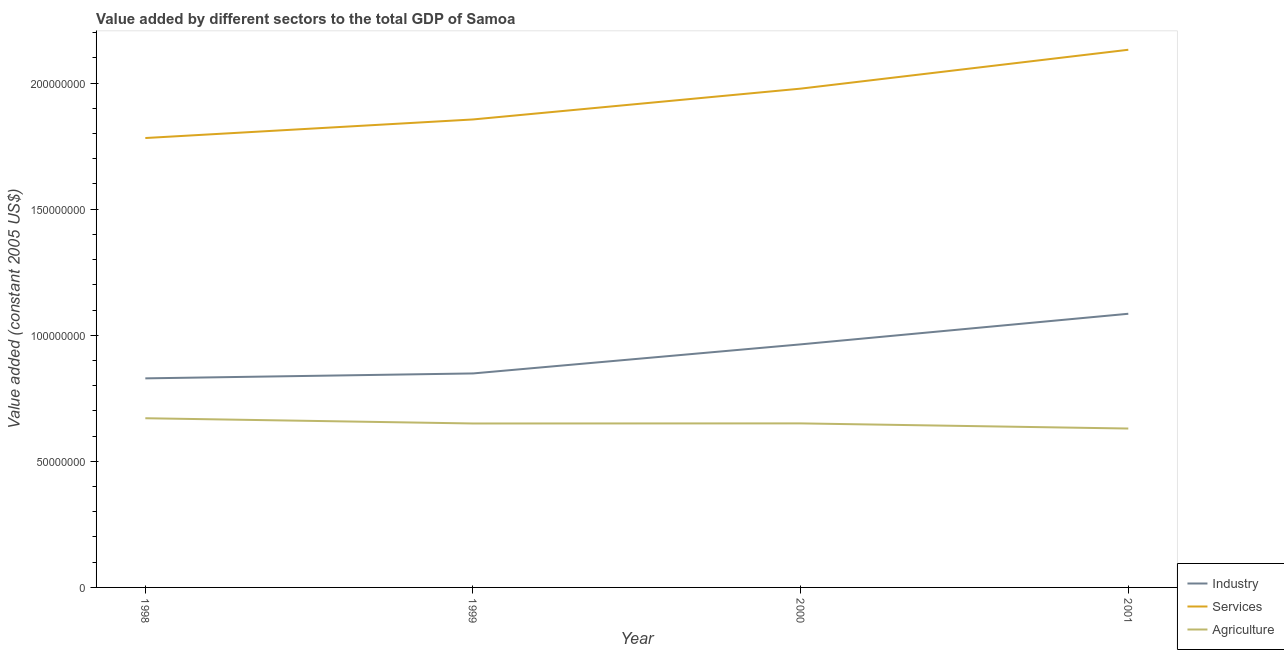Does the line corresponding to value added by services intersect with the line corresponding to value added by industrial sector?
Offer a very short reply. No. What is the value added by agricultural sector in 1999?
Provide a succinct answer. 6.50e+07. Across all years, what is the maximum value added by services?
Provide a short and direct response. 2.13e+08. Across all years, what is the minimum value added by services?
Ensure brevity in your answer.  1.78e+08. In which year was the value added by services minimum?
Offer a very short reply. 1998. What is the total value added by industrial sector in the graph?
Give a very brief answer. 3.73e+08. What is the difference between the value added by agricultural sector in 2000 and that in 2001?
Keep it short and to the point. 2.03e+06. What is the difference between the value added by services in 1999 and the value added by industrial sector in 2000?
Your answer should be very brief. 8.92e+07. What is the average value added by agricultural sector per year?
Make the answer very short. 6.50e+07. In the year 1999, what is the difference between the value added by agricultural sector and value added by services?
Provide a short and direct response. -1.21e+08. In how many years, is the value added by industrial sector greater than 80000000 US$?
Keep it short and to the point. 4. What is the ratio of the value added by services in 2000 to that in 2001?
Your response must be concise. 0.93. What is the difference between the highest and the second highest value added by agricultural sector?
Keep it short and to the point. 2.05e+06. What is the difference between the highest and the lowest value added by industrial sector?
Give a very brief answer. 2.56e+07. In how many years, is the value added by agricultural sector greater than the average value added by agricultural sector taken over all years?
Offer a terse response. 2. Is the sum of the value added by industrial sector in 1998 and 1999 greater than the maximum value added by services across all years?
Keep it short and to the point. No. Does the value added by industrial sector monotonically increase over the years?
Offer a terse response. Yes. How many lines are there?
Your response must be concise. 3. How many years are there in the graph?
Offer a very short reply. 4. How many legend labels are there?
Provide a succinct answer. 3. How are the legend labels stacked?
Offer a very short reply. Vertical. What is the title of the graph?
Provide a short and direct response. Value added by different sectors to the total GDP of Samoa. What is the label or title of the Y-axis?
Your answer should be very brief. Value added (constant 2005 US$). What is the Value added (constant 2005 US$) in Industry in 1998?
Provide a succinct answer. 8.29e+07. What is the Value added (constant 2005 US$) of Services in 1998?
Your answer should be compact. 1.78e+08. What is the Value added (constant 2005 US$) of Agriculture in 1998?
Provide a succinct answer. 6.71e+07. What is the Value added (constant 2005 US$) in Industry in 1999?
Make the answer very short. 8.48e+07. What is the Value added (constant 2005 US$) of Services in 1999?
Make the answer very short. 1.86e+08. What is the Value added (constant 2005 US$) in Agriculture in 1999?
Your response must be concise. 6.50e+07. What is the Value added (constant 2005 US$) of Industry in 2000?
Your answer should be very brief. 9.64e+07. What is the Value added (constant 2005 US$) in Services in 2000?
Make the answer very short. 1.98e+08. What is the Value added (constant 2005 US$) in Agriculture in 2000?
Offer a very short reply. 6.50e+07. What is the Value added (constant 2005 US$) in Industry in 2001?
Ensure brevity in your answer.  1.09e+08. What is the Value added (constant 2005 US$) of Services in 2001?
Provide a succinct answer. 2.13e+08. What is the Value added (constant 2005 US$) in Agriculture in 2001?
Your answer should be very brief. 6.30e+07. Across all years, what is the maximum Value added (constant 2005 US$) in Industry?
Your response must be concise. 1.09e+08. Across all years, what is the maximum Value added (constant 2005 US$) in Services?
Your answer should be compact. 2.13e+08. Across all years, what is the maximum Value added (constant 2005 US$) of Agriculture?
Offer a very short reply. 6.71e+07. Across all years, what is the minimum Value added (constant 2005 US$) in Industry?
Provide a succinct answer. 8.29e+07. Across all years, what is the minimum Value added (constant 2005 US$) of Services?
Keep it short and to the point. 1.78e+08. Across all years, what is the minimum Value added (constant 2005 US$) of Agriculture?
Offer a terse response. 6.30e+07. What is the total Value added (constant 2005 US$) in Industry in the graph?
Provide a succinct answer. 3.73e+08. What is the total Value added (constant 2005 US$) in Services in the graph?
Offer a very short reply. 7.75e+08. What is the total Value added (constant 2005 US$) in Agriculture in the graph?
Keep it short and to the point. 2.60e+08. What is the difference between the Value added (constant 2005 US$) of Industry in 1998 and that in 1999?
Make the answer very short. -1.95e+06. What is the difference between the Value added (constant 2005 US$) of Services in 1998 and that in 1999?
Your answer should be compact. -7.37e+06. What is the difference between the Value added (constant 2005 US$) of Agriculture in 1998 and that in 1999?
Ensure brevity in your answer.  2.08e+06. What is the difference between the Value added (constant 2005 US$) in Industry in 1998 and that in 2000?
Your response must be concise. -1.35e+07. What is the difference between the Value added (constant 2005 US$) of Services in 1998 and that in 2000?
Your answer should be very brief. -1.96e+07. What is the difference between the Value added (constant 2005 US$) in Agriculture in 1998 and that in 2000?
Give a very brief answer. 2.05e+06. What is the difference between the Value added (constant 2005 US$) in Industry in 1998 and that in 2001?
Your response must be concise. -2.56e+07. What is the difference between the Value added (constant 2005 US$) in Services in 1998 and that in 2001?
Your response must be concise. -3.50e+07. What is the difference between the Value added (constant 2005 US$) in Agriculture in 1998 and that in 2001?
Ensure brevity in your answer.  4.08e+06. What is the difference between the Value added (constant 2005 US$) of Industry in 1999 and that in 2000?
Make the answer very short. -1.15e+07. What is the difference between the Value added (constant 2005 US$) of Services in 1999 and that in 2000?
Offer a terse response. -1.22e+07. What is the difference between the Value added (constant 2005 US$) of Agriculture in 1999 and that in 2000?
Provide a succinct answer. -3.66e+04. What is the difference between the Value added (constant 2005 US$) of Industry in 1999 and that in 2001?
Give a very brief answer. -2.37e+07. What is the difference between the Value added (constant 2005 US$) in Services in 1999 and that in 2001?
Offer a terse response. -2.76e+07. What is the difference between the Value added (constant 2005 US$) in Agriculture in 1999 and that in 2001?
Provide a succinct answer. 2.00e+06. What is the difference between the Value added (constant 2005 US$) of Industry in 2000 and that in 2001?
Your response must be concise. -1.21e+07. What is the difference between the Value added (constant 2005 US$) of Services in 2000 and that in 2001?
Your answer should be very brief. -1.54e+07. What is the difference between the Value added (constant 2005 US$) of Agriculture in 2000 and that in 2001?
Make the answer very short. 2.03e+06. What is the difference between the Value added (constant 2005 US$) in Industry in 1998 and the Value added (constant 2005 US$) in Services in 1999?
Make the answer very short. -1.03e+08. What is the difference between the Value added (constant 2005 US$) in Industry in 1998 and the Value added (constant 2005 US$) in Agriculture in 1999?
Your response must be concise. 1.79e+07. What is the difference between the Value added (constant 2005 US$) in Services in 1998 and the Value added (constant 2005 US$) in Agriculture in 1999?
Keep it short and to the point. 1.13e+08. What is the difference between the Value added (constant 2005 US$) of Industry in 1998 and the Value added (constant 2005 US$) of Services in 2000?
Your answer should be very brief. -1.15e+08. What is the difference between the Value added (constant 2005 US$) of Industry in 1998 and the Value added (constant 2005 US$) of Agriculture in 2000?
Provide a short and direct response. 1.79e+07. What is the difference between the Value added (constant 2005 US$) in Services in 1998 and the Value added (constant 2005 US$) in Agriculture in 2000?
Your response must be concise. 1.13e+08. What is the difference between the Value added (constant 2005 US$) of Industry in 1998 and the Value added (constant 2005 US$) of Services in 2001?
Ensure brevity in your answer.  -1.30e+08. What is the difference between the Value added (constant 2005 US$) of Industry in 1998 and the Value added (constant 2005 US$) of Agriculture in 2001?
Provide a succinct answer. 1.99e+07. What is the difference between the Value added (constant 2005 US$) of Services in 1998 and the Value added (constant 2005 US$) of Agriculture in 2001?
Your response must be concise. 1.15e+08. What is the difference between the Value added (constant 2005 US$) of Industry in 1999 and the Value added (constant 2005 US$) of Services in 2000?
Your answer should be very brief. -1.13e+08. What is the difference between the Value added (constant 2005 US$) of Industry in 1999 and the Value added (constant 2005 US$) of Agriculture in 2000?
Offer a very short reply. 1.98e+07. What is the difference between the Value added (constant 2005 US$) in Services in 1999 and the Value added (constant 2005 US$) in Agriculture in 2000?
Your answer should be very brief. 1.21e+08. What is the difference between the Value added (constant 2005 US$) of Industry in 1999 and the Value added (constant 2005 US$) of Services in 2001?
Make the answer very short. -1.28e+08. What is the difference between the Value added (constant 2005 US$) in Industry in 1999 and the Value added (constant 2005 US$) in Agriculture in 2001?
Your response must be concise. 2.18e+07. What is the difference between the Value added (constant 2005 US$) in Services in 1999 and the Value added (constant 2005 US$) in Agriculture in 2001?
Make the answer very short. 1.23e+08. What is the difference between the Value added (constant 2005 US$) of Industry in 2000 and the Value added (constant 2005 US$) of Services in 2001?
Your answer should be very brief. -1.17e+08. What is the difference between the Value added (constant 2005 US$) of Industry in 2000 and the Value added (constant 2005 US$) of Agriculture in 2001?
Your response must be concise. 3.34e+07. What is the difference between the Value added (constant 2005 US$) in Services in 2000 and the Value added (constant 2005 US$) in Agriculture in 2001?
Your answer should be very brief. 1.35e+08. What is the average Value added (constant 2005 US$) in Industry per year?
Your response must be concise. 9.32e+07. What is the average Value added (constant 2005 US$) in Services per year?
Provide a succinct answer. 1.94e+08. What is the average Value added (constant 2005 US$) of Agriculture per year?
Give a very brief answer. 6.50e+07. In the year 1998, what is the difference between the Value added (constant 2005 US$) in Industry and Value added (constant 2005 US$) in Services?
Keep it short and to the point. -9.53e+07. In the year 1998, what is the difference between the Value added (constant 2005 US$) of Industry and Value added (constant 2005 US$) of Agriculture?
Your answer should be very brief. 1.58e+07. In the year 1998, what is the difference between the Value added (constant 2005 US$) in Services and Value added (constant 2005 US$) in Agriculture?
Ensure brevity in your answer.  1.11e+08. In the year 1999, what is the difference between the Value added (constant 2005 US$) in Industry and Value added (constant 2005 US$) in Services?
Offer a very short reply. -1.01e+08. In the year 1999, what is the difference between the Value added (constant 2005 US$) of Industry and Value added (constant 2005 US$) of Agriculture?
Make the answer very short. 1.98e+07. In the year 1999, what is the difference between the Value added (constant 2005 US$) in Services and Value added (constant 2005 US$) in Agriculture?
Offer a very short reply. 1.21e+08. In the year 2000, what is the difference between the Value added (constant 2005 US$) of Industry and Value added (constant 2005 US$) of Services?
Keep it short and to the point. -1.01e+08. In the year 2000, what is the difference between the Value added (constant 2005 US$) in Industry and Value added (constant 2005 US$) in Agriculture?
Your response must be concise. 3.13e+07. In the year 2000, what is the difference between the Value added (constant 2005 US$) in Services and Value added (constant 2005 US$) in Agriculture?
Offer a very short reply. 1.33e+08. In the year 2001, what is the difference between the Value added (constant 2005 US$) in Industry and Value added (constant 2005 US$) in Services?
Offer a very short reply. -1.05e+08. In the year 2001, what is the difference between the Value added (constant 2005 US$) of Industry and Value added (constant 2005 US$) of Agriculture?
Ensure brevity in your answer.  4.55e+07. In the year 2001, what is the difference between the Value added (constant 2005 US$) of Services and Value added (constant 2005 US$) of Agriculture?
Your response must be concise. 1.50e+08. What is the ratio of the Value added (constant 2005 US$) in Industry in 1998 to that in 1999?
Your answer should be very brief. 0.98. What is the ratio of the Value added (constant 2005 US$) in Services in 1998 to that in 1999?
Your response must be concise. 0.96. What is the ratio of the Value added (constant 2005 US$) of Agriculture in 1998 to that in 1999?
Keep it short and to the point. 1.03. What is the ratio of the Value added (constant 2005 US$) of Industry in 1998 to that in 2000?
Your response must be concise. 0.86. What is the ratio of the Value added (constant 2005 US$) of Services in 1998 to that in 2000?
Ensure brevity in your answer.  0.9. What is the ratio of the Value added (constant 2005 US$) in Agriculture in 1998 to that in 2000?
Keep it short and to the point. 1.03. What is the ratio of the Value added (constant 2005 US$) in Industry in 1998 to that in 2001?
Make the answer very short. 0.76. What is the ratio of the Value added (constant 2005 US$) in Services in 1998 to that in 2001?
Your answer should be very brief. 0.84. What is the ratio of the Value added (constant 2005 US$) in Agriculture in 1998 to that in 2001?
Your response must be concise. 1.06. What is the ratio of the Value added (constant 2005 US$) in Industry in 1999 to that in 2000?
Your response must be concise. 0.88. What is the ratio of the Value added (constant 2005 US$) of Services in 1999 to that in 2000?
Offer a terse response. 0.94. What is the ratio of the Value added (constant 2005 US$) of Agriculture in 1999 to that in 2000?
Make the answer very short. 1. What is the ratio of the Value added (constant 2005 US$) in Industry in 1999 to that in 2001?
Ensure brevity in your answer.  0.78. What is the ratio of the Value added (constant 2005 US$) of Services in 1999 to that in 2001?
Your response must be concise. 0.87. What is the ratio of the Value added (constant 2005 US$) of Agriculture in 1999 to that in 2001?
Keep it short and to the point. 1.03. What is the ratio of the Value added (constant 2005 US$) of Industry in 2000 to that in 2001?
Make the answer very short. 0.89. What is the ratio of the Value added (constant 2005 US$) of Services in 2000 to that in 2001?
Provide a succinct answer. 0.93. What is the ratio of the Value added (constant 2005 US$) in Agriculture in 2000 to that in 2001?
Give a very brief answer. 1.03. What is the difference between the highest and the second highest Value added (constant 2005 US$) of Industry?
Make the answer very short. 1.21e+07. What is the difference between the highest and the second highest Value added (constant 2005 US$) of Services?
Ensure brevity in your answer.  1.54e+07. What is the difference between the highest and the second highest Value added (constant 2005 US$) in Agriculture?
Provide a short and direct response. 2.05e+06. What is the difference between the highest and the lowest Value added (constant 2005 US$) of Industry?
Your answer should be compact. 2.56e+07. What is the difference between the highest and the lowest Value added (constant 2005 US$) in Services?
Provide a succinct answer. 3.50e+07. What is the difference between the highest and the lowest Value added (constant 2005 US$) in Agriculture?
Provide a succinct answer. 4.08e+06. 